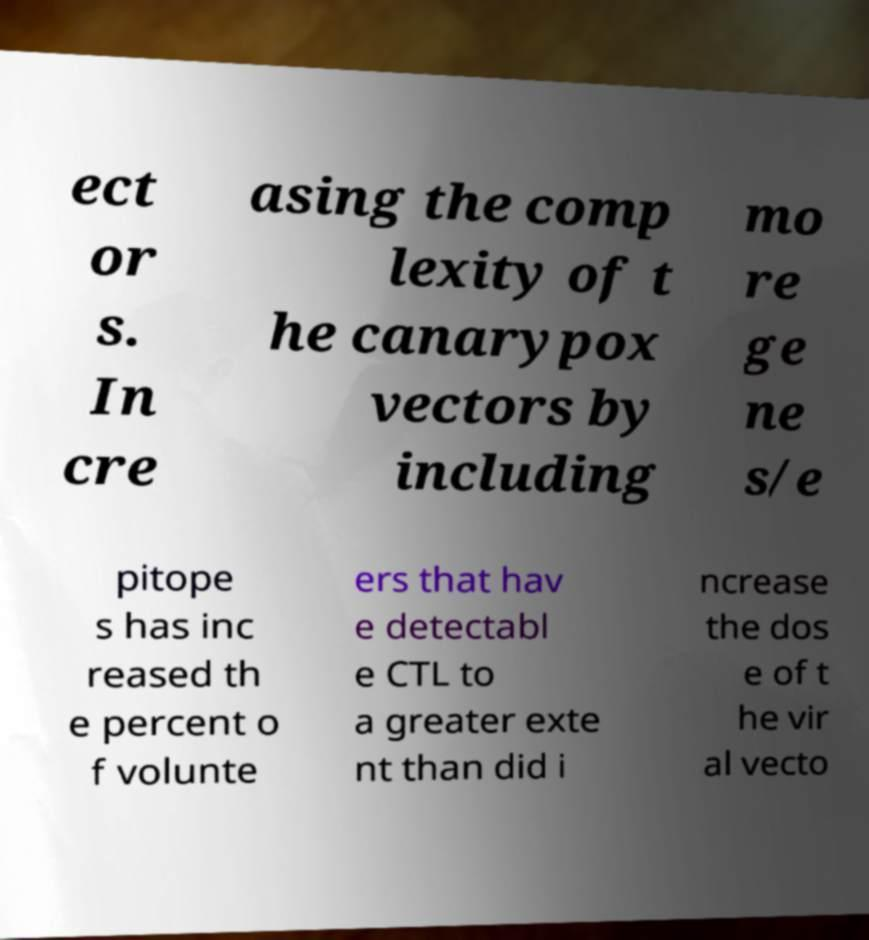Can you read and provide the text displayed in the image?This photo seems to have some interesting text. Can you extract and type it out for me? ect or s. In cre asing the comp lexity of t he canarypox vectors by including mo re ge ne s/e pitope s has inc reased th e percent o f volunte ers that hav e detectabl e CTL to a greater exte nt than did i ncrease the dos e of t he vir al vecto 